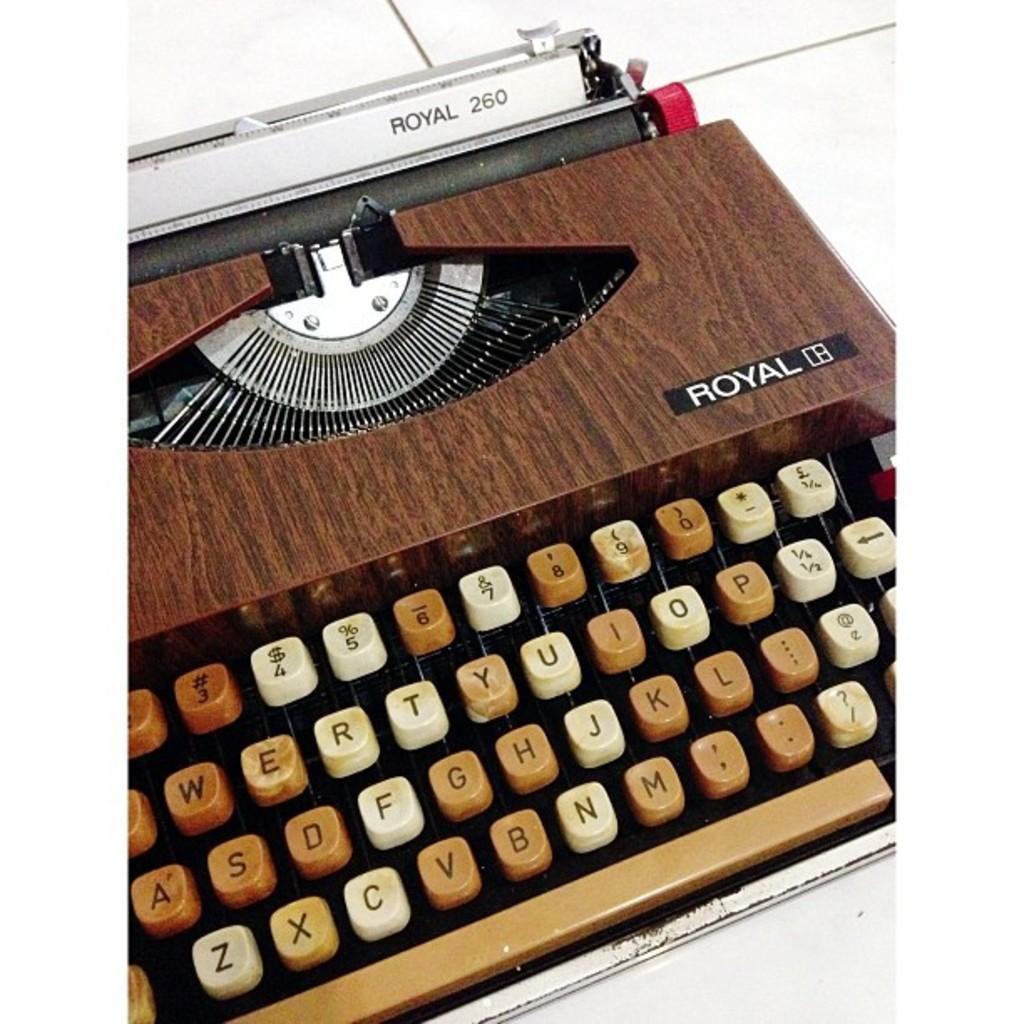What brand is this typewriter?
Ensure brevity in your answer.  Royal. Which model is the royal typewritter?
Offer a very short reply. 260. 